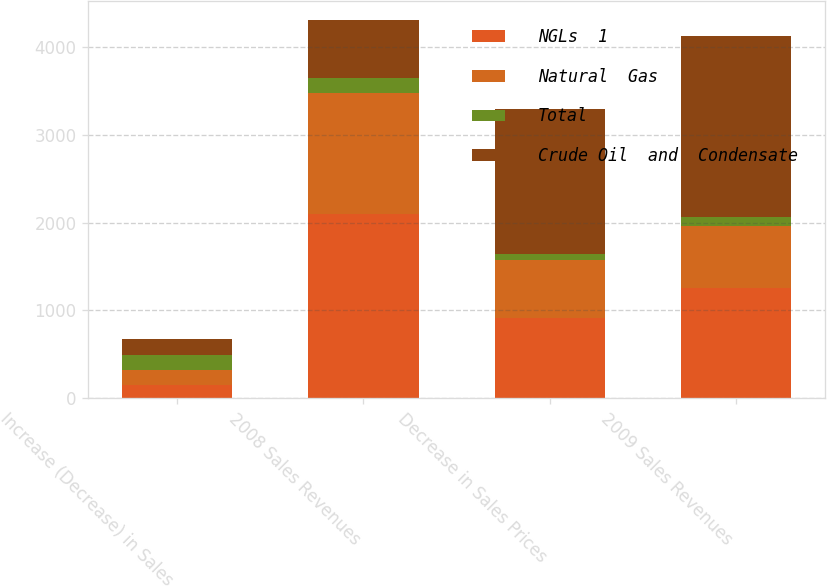Convert chart. <chart><loc_0><loc_0><loc_500><loc_500><stacked_bar_chart><ecel><fcel>Increase (Decrease) in Sales<fcel>2008 Sales Revenues<fcel>Decrease in Sales Prices<fcel>2009 Sales Revenues<nl><fcel>NGLs  1<fcel>152<fcel>2101<fcel>915<fcel>1261<nl><fcel>Natural  Gas<fcel>165<fcel>1375<fcel>655<fcel>701<nl><fcel>Total<fcel>175<fcel>175<fcel>77<fcel>98<nl><fcel>Crude Oil  and  Condensate<fcel>188<fcel>655<fcel>1647<fcel>2060<nl></chart> 